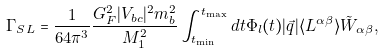Convert formula to latex. <formula><loc_0><loc_0><loc_500><loc_500>\Gamma _ { S L } = \frac { 1 } { 6 4 \pi ^ { 3 } } \frac { G _ { F } ^ { 2 } | V _ { b c } | ^ { 2 } m _ { b } ^ { 2 } } { M _ { 1 } ^ { 2 } } \int _ { t _ { \min } } ^ { t _ { \max } } d t \Phi _ { l } ( t ) | \vec { q } | \langle L ^ { \alpha \beta } \rangle \tilde { W } _ { \alpha \beta } ,</formula> 